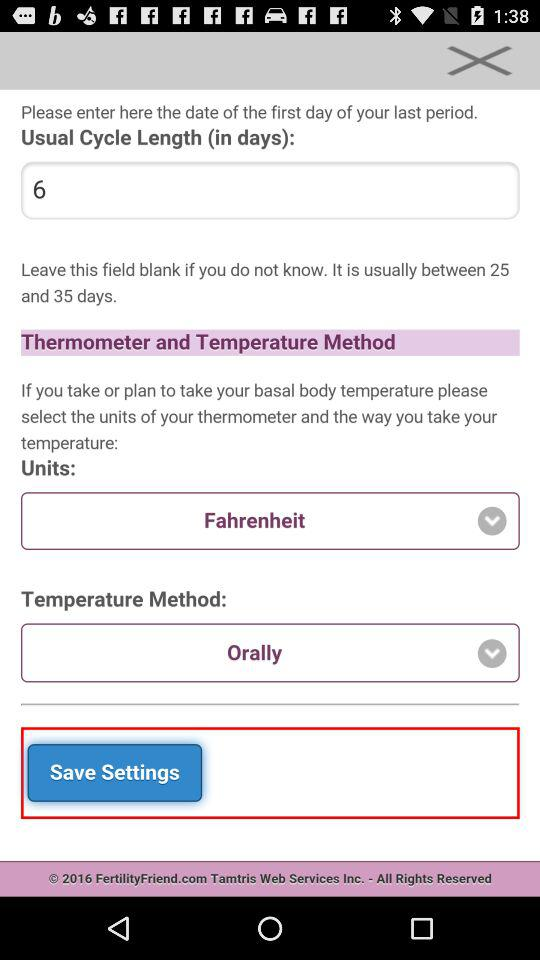What is the usual cycle length in days? The usual cycle length is 6 days. 